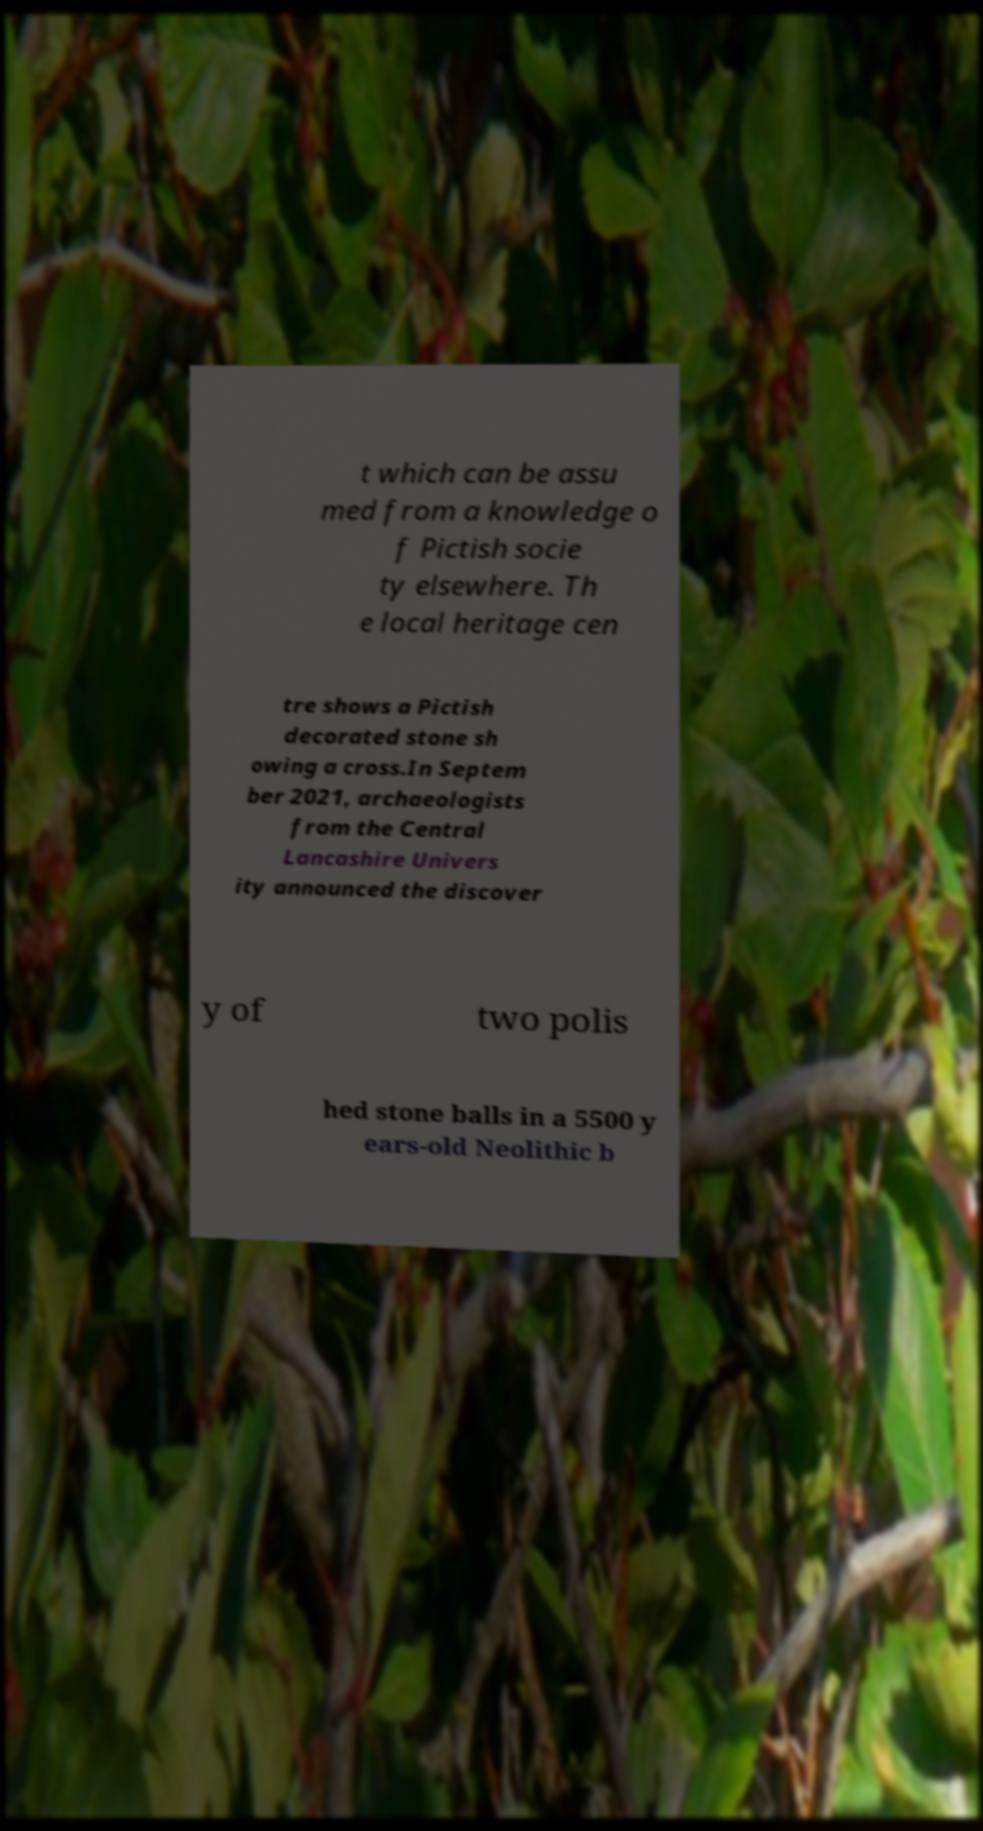Can you accurately transcribe the text from the provided image for me? t which can be assu med from a knowledge o f Pictish socie ty elsewhere. Th e local heritage cen tre shows a Pictish decorated stone sh owing a cross.In Septem ber 2021, archaeologists from the Central Lancashire Univers ity announced the discover y of two polis hed stone balls in a 5500 y ears-old Neolithic b 